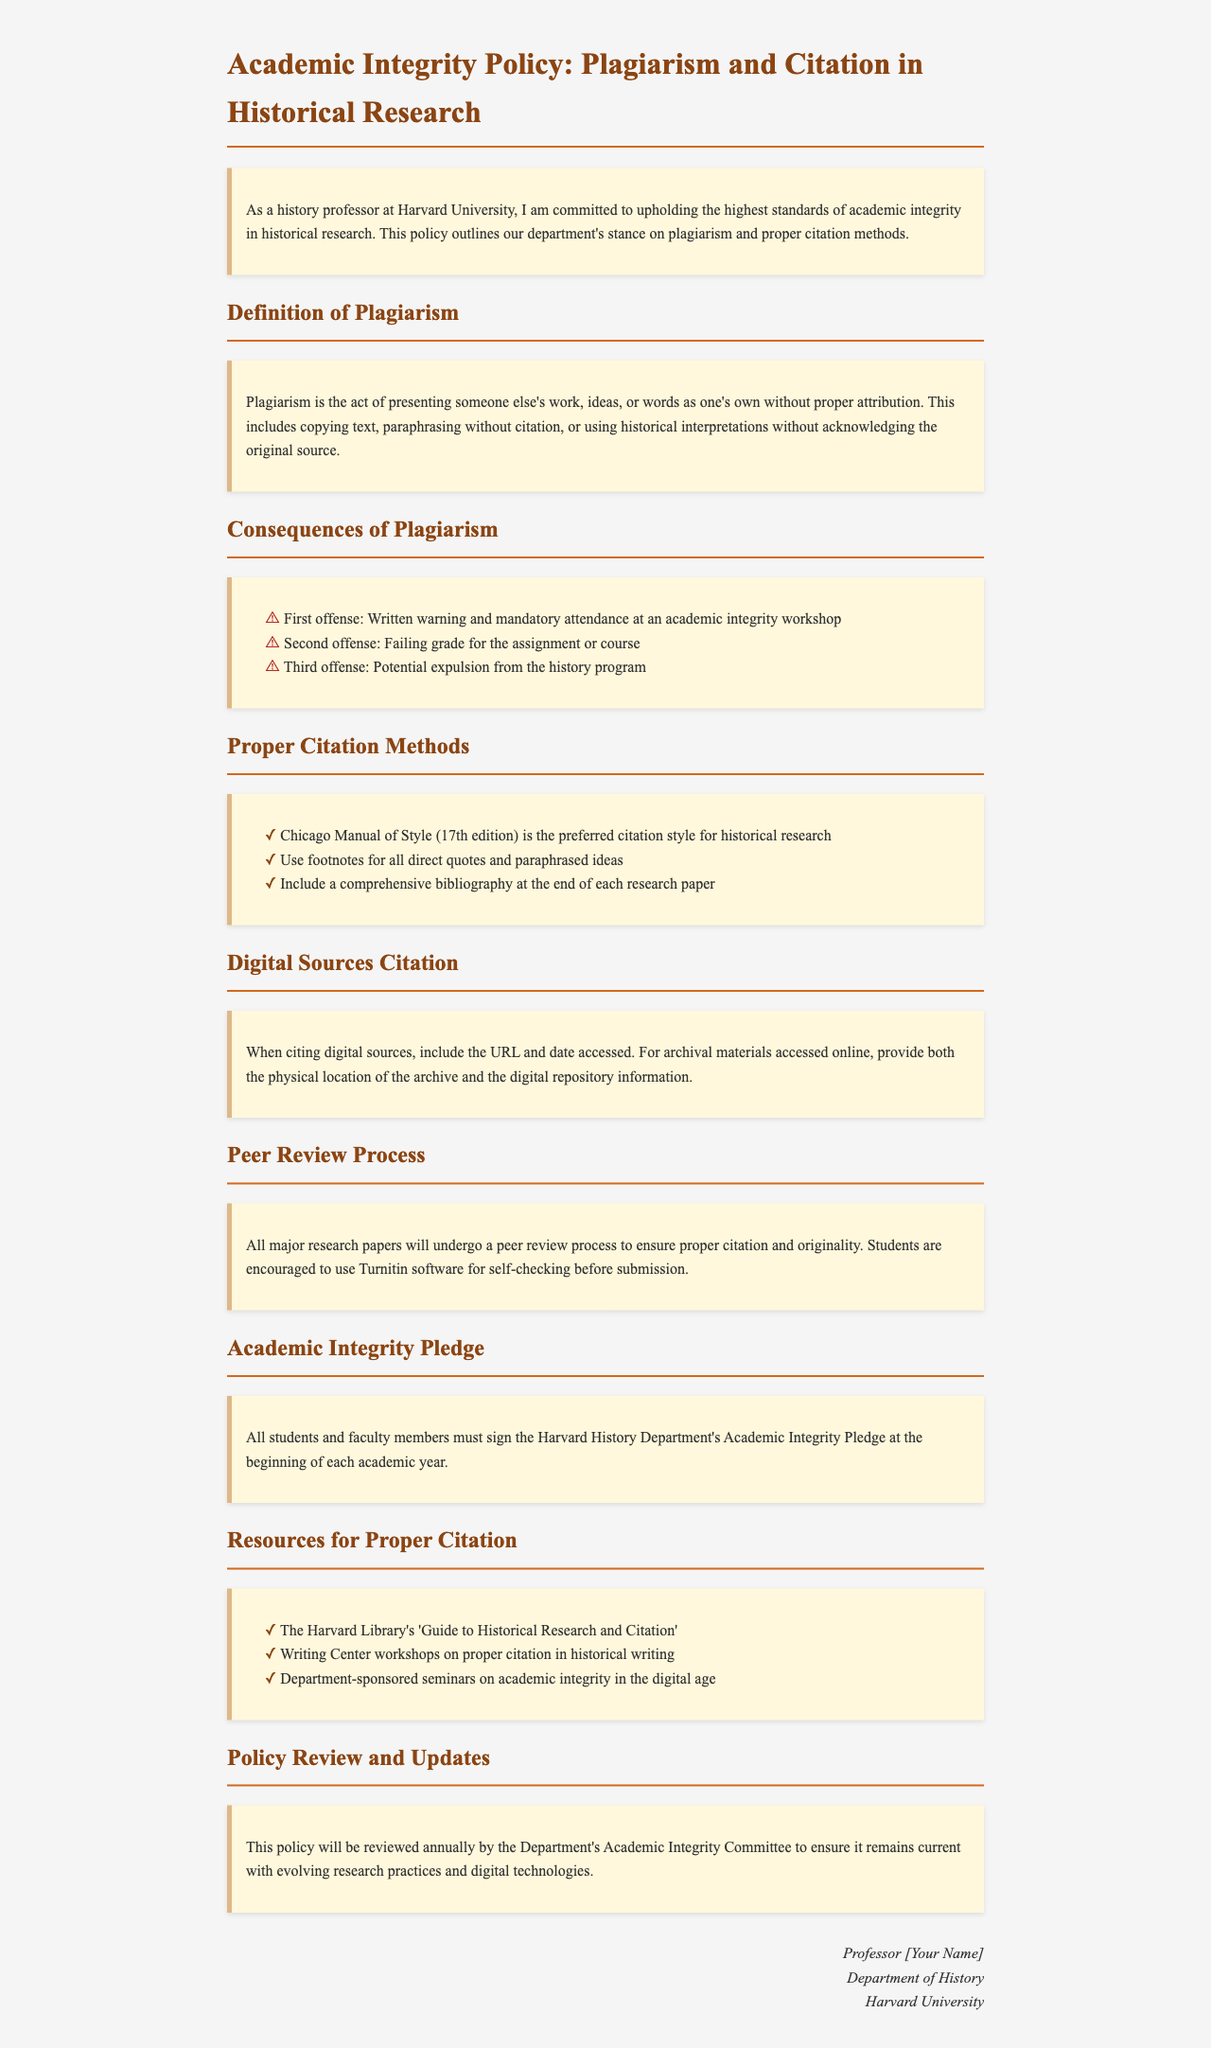What is the preferred citation style? The document states that the preferred citation style for historical research is the Chicago Manual of Style (17th edition).
Answer: Chicago Manual of Style (17th edition) What happens on the first offense of plagiarism? According to the document, the consequence for the first offense is a written warning and mandatory attendance at an academic integrity workshop.
Answer: Written warning and mandatory attendance at an academic integrity workshop What must students and faculty sign each year? The document mentions that all students and faculty members must sign the Harvard History Department's Academic Integrity Pledge at the beginning of each academic year.
Answer: Academic Integrity Pledge What should be included when citing digital sources? The document specifies that when citing digital sources, one should include the URL and date accessed.
Answer: URL and date accessed How often will the policy be reviewed? The policy will be reviewed annually by the Department's Academic Integrity Committee.
Answer: Annually What is required for a second offense of plagiarism? For the second offense, the document states that the consequence is a failing grade for the assignment or course.
Answer: Failing grade for the assignment or course What resources are available for proper citation? The document lists several resources, including the Harvard Library's 'Guide to Historical Research and Citation'.
Answer: Harvard Library's 'Guide to Historical Research and Citation' What type of process will major research papers undergo? The document indicates that all major research papers will undergo a peer review process to ensure proper citation and originality.
Answer: Peer review process 